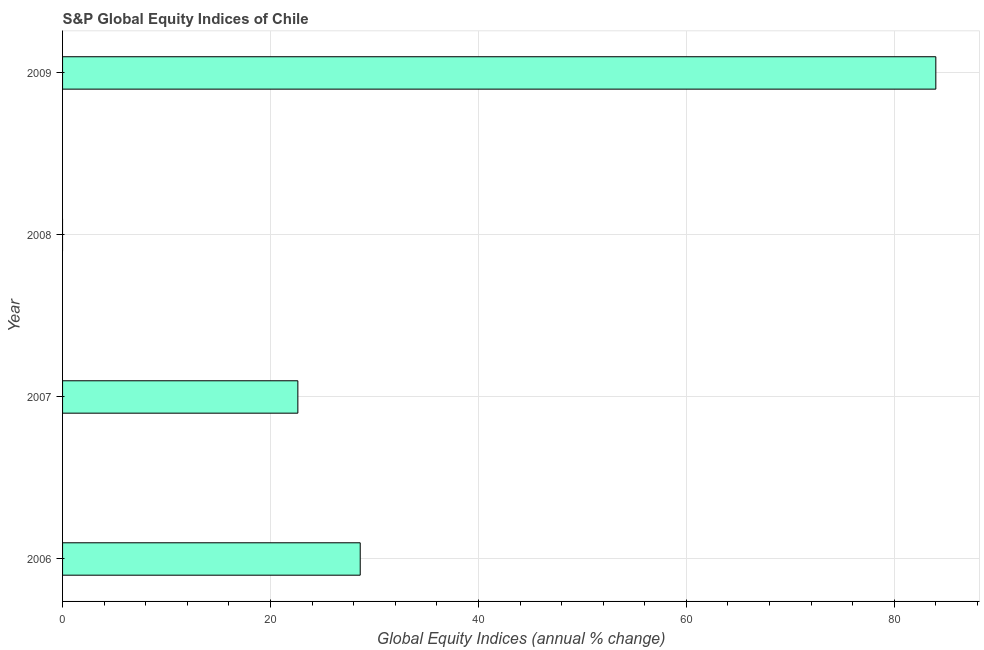Does the graph contain grids?
Offer a very short reply. Yes. What is the title of the graph?
Offer a terse response. S&P Global Equity Indices of Chile. What is the label or title of the X-axis?
Give a very brief answer. Global Equity Indices (annual % change). What is the label or title of the Y-axis?
Offer a very short reply. Year. What is the s&p global equity indices in 2006?
Keep it short and to the point. 28.63. Across all years, what is the maximum s&p global equity indices?
Offer a terse response. 83.99. What is the sum of the s&p global equity indices?
Offer a terse response. 135.25. What is the difference between the s&p global equity indices in 2006 and 2009?
Provide a short and direct response. -55.36. What is the average s&p global equity indices per year?
Offer a very short reply. 33.81. What is the median s&p global equity indices?
Your answer should be compact. 25.63. In how many years, is the s&p global equity indices greater than 80 %?
Provide a succinct answer. 1. What is the ratio of the s&p global equity indices in 2007 to that in 2009?
Keep it short and to the point. 0.27. Is the difference between the s&p global equity indices in 2006 and 2009 greater than the difference between any two years?
Give a very brief answer. No. What is the difference between the highest and the second highest s&p global equity indices?
Provide a succinct answer. 55.36. What is the difference between the highest and the lowest s&p global equity indices?
Offer a very short reply. 83.99. In how many years, is the s&p global equity indices greater than the average s&p global equity indices taken over all years?
Keep it short and to the point. 1. Are all the bars in the graph horizontal?
Make the answer very short. Yes. What is the difference between two consecutive major ticks on the X-axis?
Give a very brief answer. 20. Are the values on the major ticks of X-axis written in scientific E-notation?
Your answer should be very brief. No. What is the Global Equity Indices (annual % change) in 2006?
Your answer should be very brief. 28.63. What is the Global Equity Indices (annual % change) of 2007?
Offer a very short reply. 22.63. What is the Global Equity Indices (annual % change) in 2008?
Your response must be concise. 0. What is the Global Equity Indices (annual % change) of 2009?
Your response must be concise. 83.99. What is the difference between the Global Equity Indices (annual % change) in 2006 and 2007?
Provide a short and direct response. 6. What is the difference between the Global Equity Indices (annual % change) in 2006 and 2009?
Ensure brevity in your answer.  -55.36. What is the difference between the Global Equity Indices (annual % change) in 2007 and 2009?
Offer a very short reply. -61.36. What is the ratio of the Global Equity Indices (annual % change) in 2006 to that in 2007?
Provide a succinct answer. 1.26. What is the ratio of the Global Equity Indices (annual % change) in 2006 to that in 2009?
Your response must be concise. 0.34. What is the ratio of the Global Equity Indices (annual % change) in 2007 to that in 2009?
Make the answer very short. 0.27. 